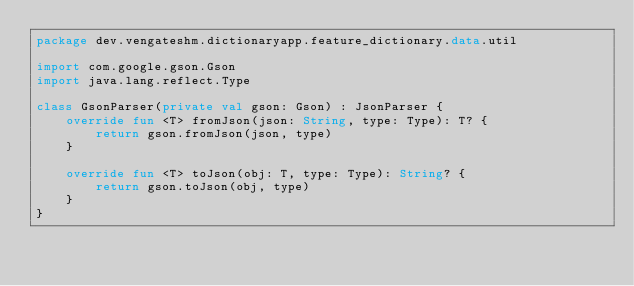<code> <loc_0><loc_0><loc_500><loc_500><_Kotlin_>package dev.vengateshm.dictionaryapp.feature_dictionary.data.util

import com.google.gson.Gson
import java.lang.reflect.Type

class GsonParser(private val gson: Gson) : JsonParser {
    override fun <T> fromJson(json: String, type: Type): T? {
        return gson.fromJson(json, type)
    }

    override fun <T> toJson(obj: T, type: Type): String? {
        return gson.toJson(obj, type)
    }
}</code> 